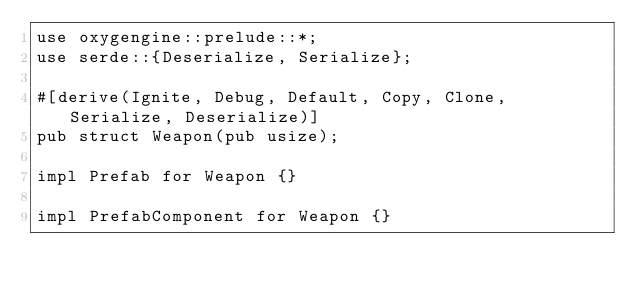<code> <loc_0><loc_0><loc_500><loc_500><_Rust_>use oxygengine::prelude::*;
use serde::{Deserialize, Serialize};

#[derive(Ignite, Debug, Default, Copy, Clone, Serialize, Deserialize)]
pub struct Weapon(pub usize);

impl Prefab for Weapon {}

impl PrefabComponent for Weapon {}
</code> 